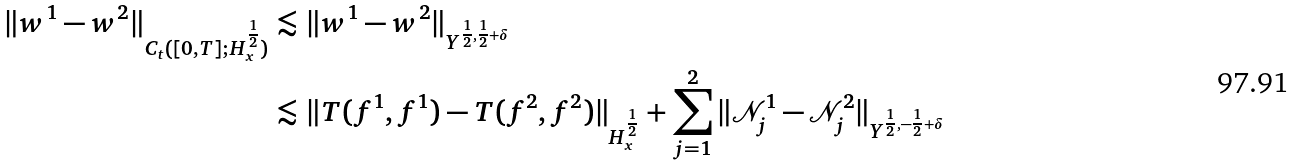<formula> <loc_0><loc_0><loc_500><loc_500>\| w ^ { 1 } - w ^ { 2 } \| _ { C _ { t } ( [ 0 , T ] ; H ^ { \frac { 1 } { 2 } } _ { x } ) } & \lesssim \| w ^ { 1 } - w ^ { 2 } \| _ { Y ^ { \frac { 1 } { 2 } , \frac { 1 } { 2 } + \delta } } \\ & \lesssim \| T ( f ^ { 1 } , f ^ { 1 } ) - T ( f ^ { 2 } , f ^ { 2 } ) \| _ { H ^ { \frac { 1 } { 2 } } _ { x } } + \sum _ { j = 1 } ^ { 2 } \| \mathcal { N } ^ { 1 } _ { j } - \mathcal { N } ^ { 2 } _ { j } \| _ { Y ^ { \frac { 1 } { 2 } , - \frac { 1 } { 2 } + \delta } }</formula> 